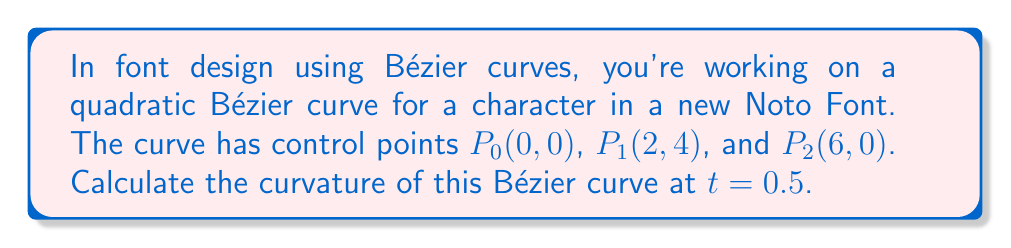Could you help me with this problem? To calculate the curvature of a quadratic Bézier curve at a specific point, we'll follow these steps:

1. The quadratic Bézier curve is defined by:
   $$B(t) = (1-t)^2P_0 + 2t(1-t)P_1 + t^2P_2$$

2. We need to find the first and second derivatives:
   $$B'(t) = 2(1-t)(P_1-P_0) + 2t(P_2-P_1)$$
   $$B''(t) = 2(P_2 - 2P_1 + P_0)$$

3. Calculate these derivatives for our curve:
   $$B'(t) = 2(1-t)((2,4)-(0,0)) + 2t((6,0)-(2,4))$$
   $$B'(t) = 2(1-t)(2,4) + 2t(4,-4)$$
   $$B''(t) = 2((6,0) - 2(2,4) + (0,0)) = 2(2,-8) = (4,-16)$$

4. At t = 0.5:
   $$B'(0.5) = (1)(2,4) + (1)(4,-4) = (6,0)$$

5. The curvature κ is given by:
   $$κ = \frac{|x'y'' - y'x''|}{(x'^2 + y'^2)^{3/2}}$$

   Where x' and y' are components of B'(0.5), and x'' and y'' are components of B''(0.5).

6. Plugging in our values:
   $$κ = \frac{|6(-16) - 0(4)|}{(6^2 + 0^2)^{3/2}} = \frac{96}{216} = \frac{4}{9}$$

Therefore, the curvature at t = 0.5 is 4/9.
Answer: $\frac{4}{9}$ 